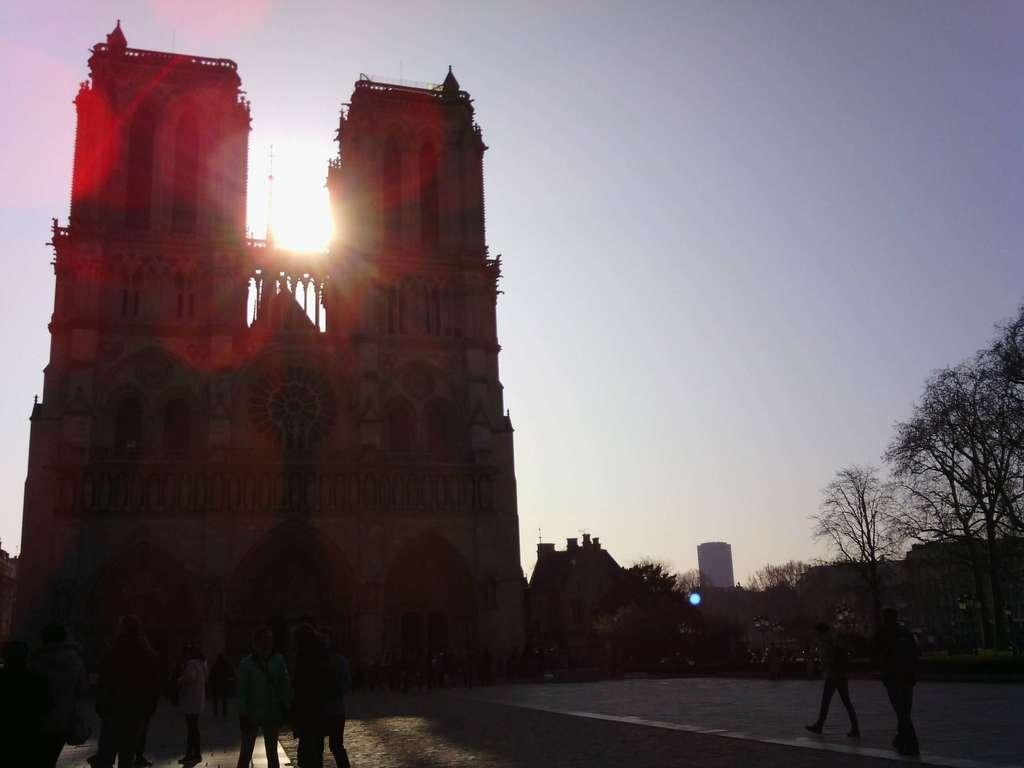What type of building is located on the left side of the image? There is a clock building on the left side of the image. What can be seen at the bottom of the image? There are people at the bottom side of the image. What other structures are present in the image besides the clock building? There are other buildings in the image. What type of vegetation is visible in the image? There are trees in the image. Can you tell me how many eyes the worm has in the image? There is no worm present in the image, so it is not possible to determine the number of eyes it might have. 